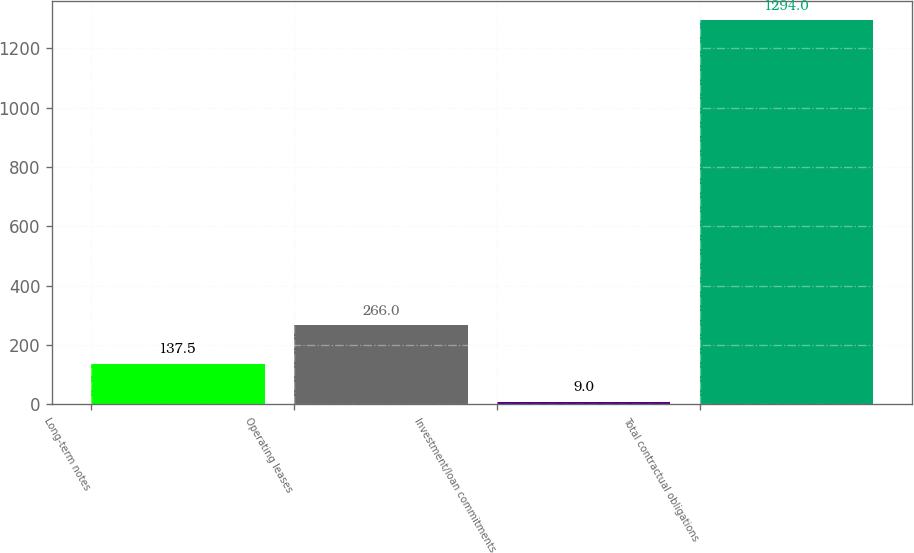Convert chart to OTSL. <chart><loc_0><loc_0><loc_500><loc_500><bar_chart><fcel>Long-term notes<fcel>Operating leases<fcel>Investment/loan commitments<fcel>Total contractual obligations<nl><fcel>137.5<fcel>266<fcel>9<fcel>1294<nl></chart> 